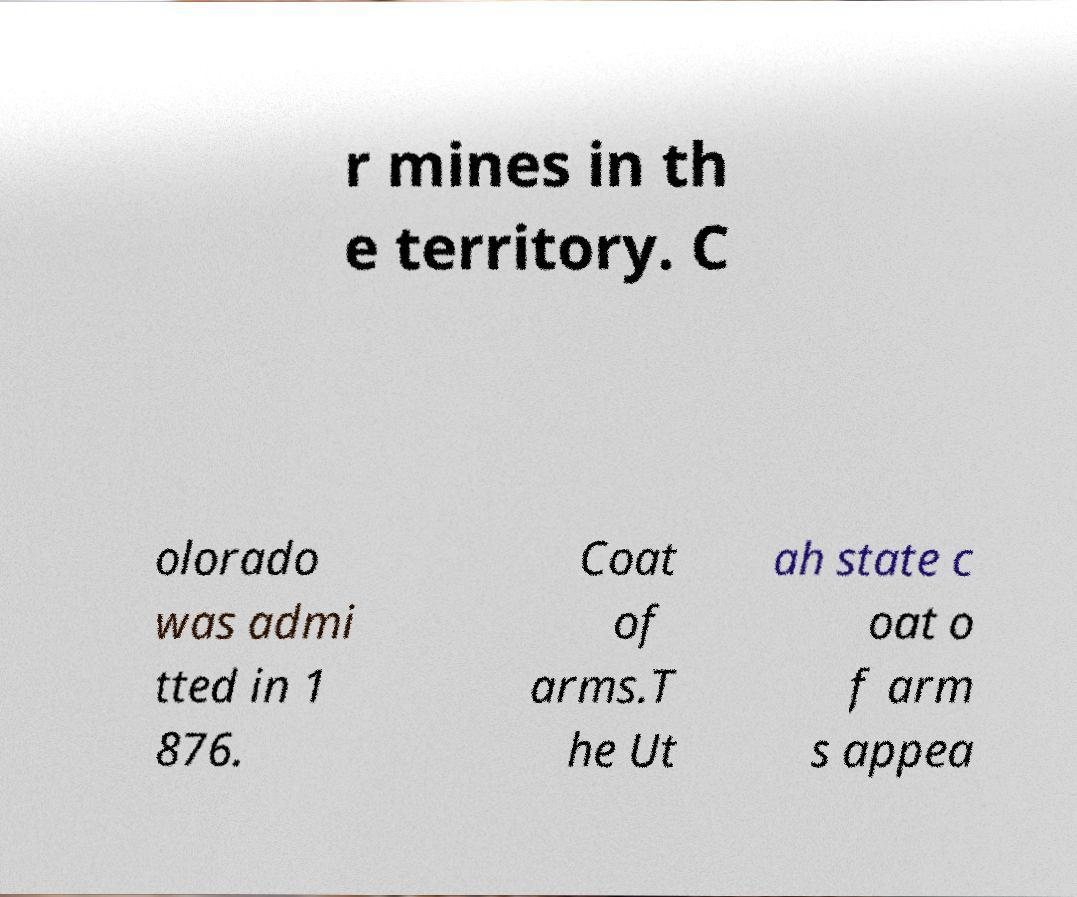Could you extract and type out the text from this image? r mines in th e territory. C olorado was admi tted in 1 876. Coat of arms.T he Ut ah state c oat o f arm s appea 